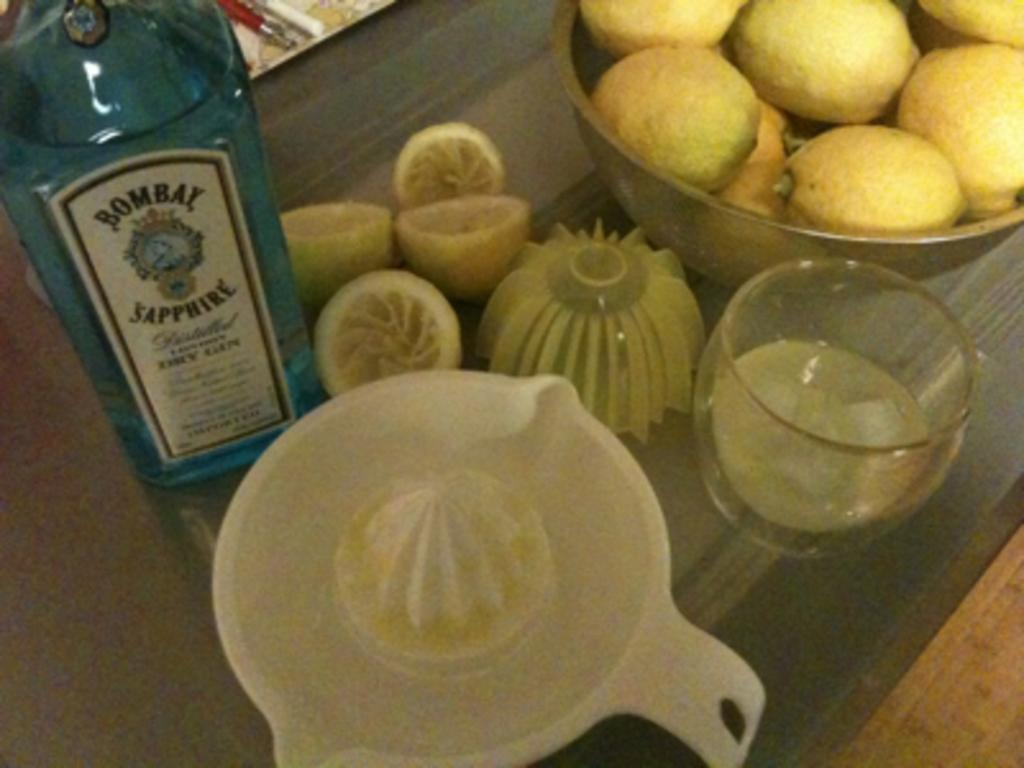What is the main object in the center of the image? There is a squeezer in the center of the image. What type of food is present in the image? There are fruits in a bowl in the image. What is the purpose of the glass in the image? The glass is likely used for drinking or holding a beverage. What is the purpose of the bottle in the image? The bottle may contain a liquid, such as juice or water, to be used with the squeezer or consumed separately. What surface is the objects placed on in the image? There is a table at the bottom of the image. How does the car fall from the sky in the image? There is no car present in the image, and therefore no falling car can be observed. 